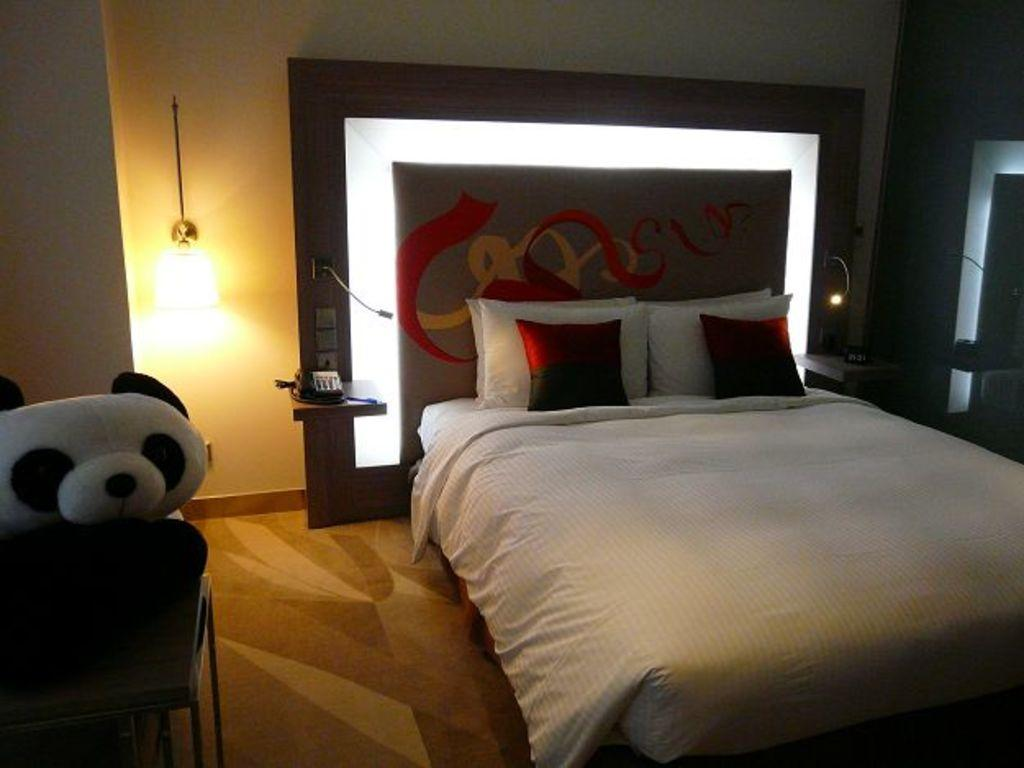What type of furniture is present in the image? There is a bed in the image. What items are used for comfort on the bed? There are pillows and cushions in the image. Where is the telephone located in the image? The telephone is on the left side of the image. What is a source of light in the image? There is a light in the image. What additional item can be seen on the left side of the image? There is a soft toy on the left side of the image. What type of bag is being used as a throne in the image? There is no bag or throne present in the image. 